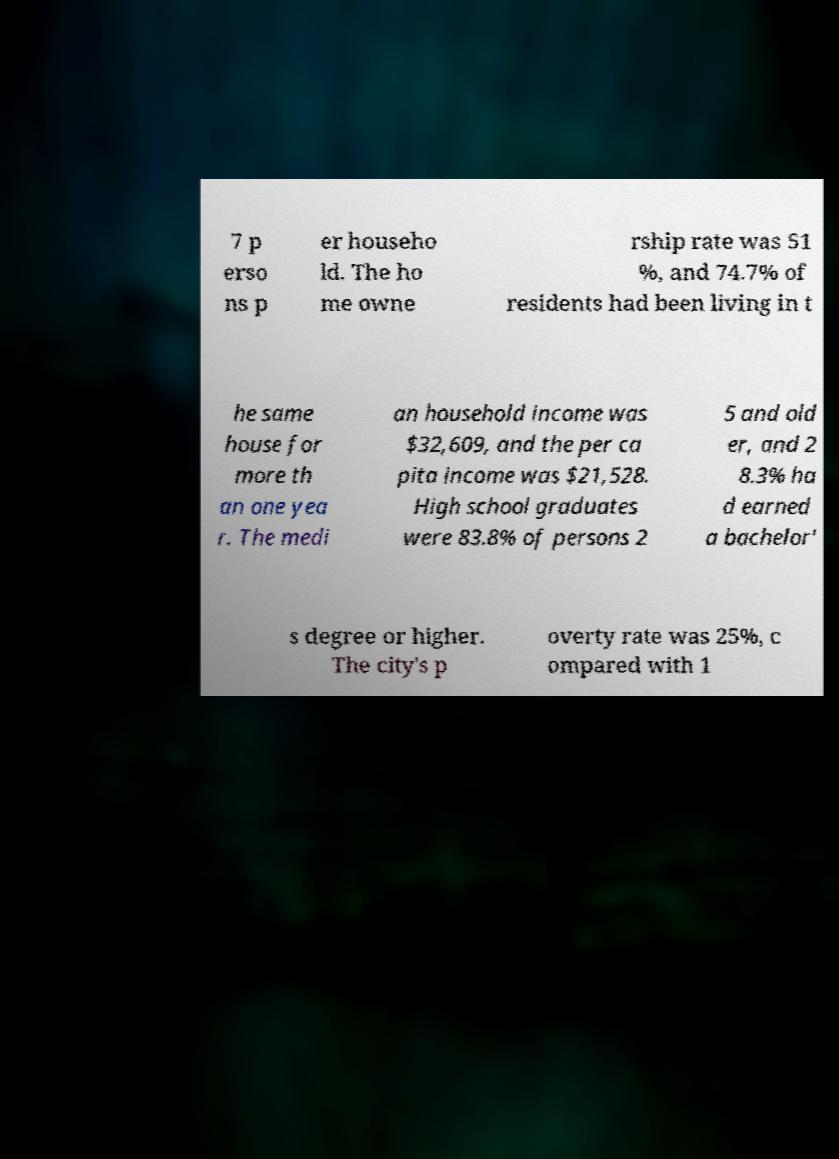Can you accurately transcribe the text from the provided image for me? 7 p erso ns p er househo ld. The ho me owne rship rate was 51 %, and 74.7% of residents had been living in t he same house for more th an one yea r. The medi an household income was $32,609, and the per ca pita income was $21,528. High school graduates were 83.8% of persons 2 5 and old er, and 2 8.3% ha d earned a bachelor' s degree or higher. The city's p overty rate was 25%, c ompared with 1 